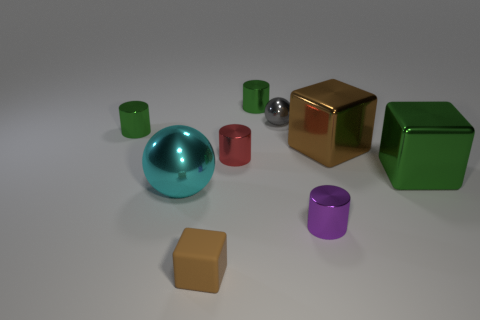Subtract all purple cylinders. How many cylinders are left? 3 Add 1 small purple metallic cylinders. How many objects exist? 10 Subtract all cubes. How many objects are left? 6 Subtract all purple cylinders. How many cylinders are left? 3 Subtract all tiny gray shiny objects. Subtract all small green objects. How many objects are left? 6 Add 7 big spheres. How many big spheres are left? 8 Add 2 brown rubber cubes. How many brown rubber cubes exist? 3 Subtract 2 green cylinders. How many objects are left? 7 Subtract 4 cylinders. How many cylinders are left? 0 Subtract all red balls. Subtract all green blocks. How many balls are left? 2 